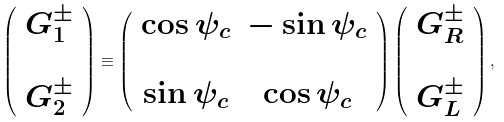Convert formula to latex. <formula><loc_0><loc_0><loc_500><loc_500>\left ( \begin{array} { c } { G } _ { 1 } ^ { \pm } \\ \\ { G } _ { 2 } ^ { \pm } \end{array} \right ) \equiv \left ( \begin{array} { c c } \cos \psi _ { c } & - \sin \psi _ { c } \\ & \\ \sin \psi _ { c } & \cos \psi _ { c } \end{array} \right ) \left ( \begin{array} { c } { G } _ { R } ^ { \pm } \\ \\ { G } _ { L } ^ { \pm } \end{array} \right ) ,</formula> 